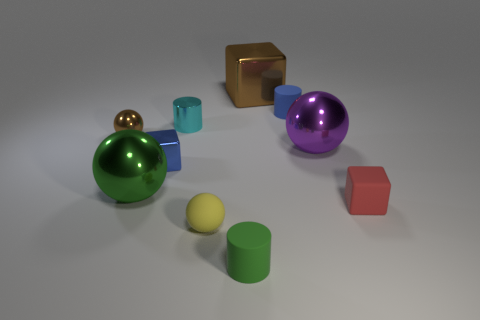Subtract all tiny matte cylinders. How many cylinders are left? 1 Subtract all brown cubes. How many cubes are left? 2 Subtract all cubes. How many objects are left? 7 Subtract 2 balls. How many balls are left? 2 Add 4 small green cylinders. How many small green cylinders exist? 5 Subtract 0 gray blocks. How many objects are left? 10 Subtract all gray balls. Subtract all red cylinders. How many balls are left? 4 Subtract all blue balls. How many brown cubes are left? 1 Subtract all small blue spheres. Subtract all green things. How many objects are left? 8 Add 8 small cyan cylinders. How many small cyan cylinders are left? 9 